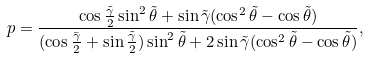Convert formula to latex. <formula><loc_0><loc_0><loc_500><loc_500>p = \frac { \cos \frac { \tilde { \gamma } } { 2 } \sin ^ { 2 } \tilde { \theta } + \sin \tilde { \gamma } ( \cos ^ { 2 } \tilde { \theta } - \cos \tilde { \theta } ) } { ( \cos \frac { \bar { \gamma } } { 2 } + \sin \frac { \tilde { \gamma } } { 2 } ) \sin ^ { 2 } \tilde { \theta } + 2 \sin \tilde { \gamma } ( \cos ^ { 2 } \tilde { \theta } - \cos \tilde { \theta } ) } ,</formula> 